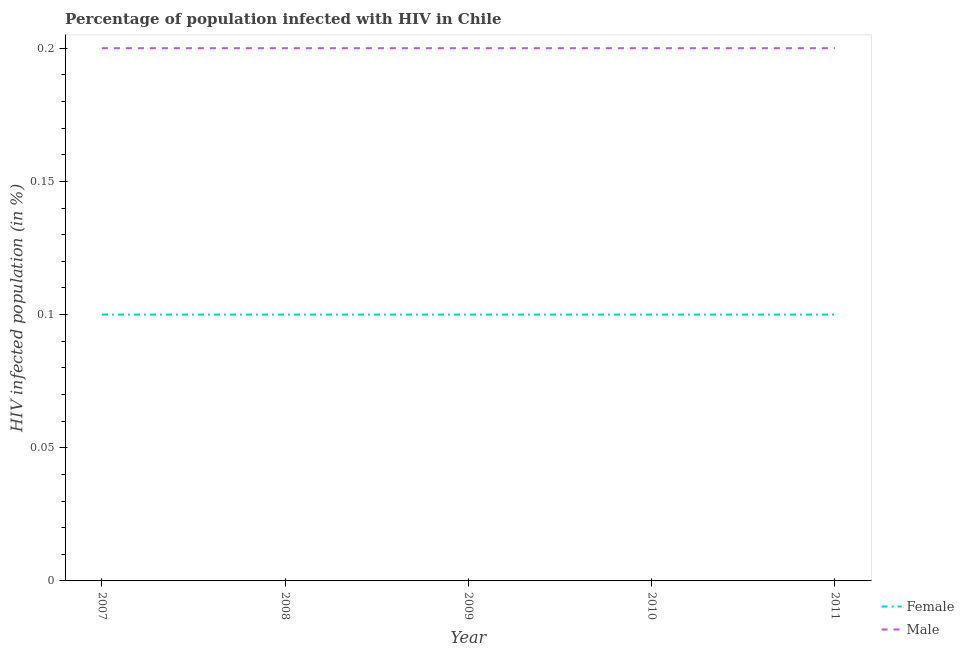Across all years, what is the maximum percentage of females who are infected with hiv?
Offer a terse response. 0.1. What is the difference between the percentage of females who are infected with hiv in 2009 and that in 2010?
Make the answer very short. 0. What is the difference between the percentage of females who are infected with hiv in 2007 and the percentage of males who are infected with hiv in 2011?
Your response must be concise. -0.1. What is the average percentage of males who are infected with hiv per year?
Your response must be concise. 0.2. In the year 2010, what is the difference between the percentage of males who are infected with hiv and percentage of females who are infected with hiv?
Give a very brief answer. 0.1. Is the difference between the percentage of females who are infected with hiv in 2009 and 2010 greater than the difference between the percentage of males who are infected with hiv in 2009 and 2010?
Provide a short and direct response. No. What is the difference between the highest and the lowest percentage of males who are infected with hiv?
Your answer should be compact. 0. Does the percentage of males who are infected with hiv monotonically increase over the years?
Provide a succinct answer. No. Is the percentage of females who are infected with hiv strictly less than the percentage of males who are infected with hiv over the years?
Offer a very short reply. Yes. How many years are there in the graph?
Provide a succinct answer. 5. What is the difference between two consecutive major ticks on the Y-axis?
Make the answer very short. 0.05. Are the values on the major ticks of Y-axis written in scientific E-notation?
Give a very brief answer. No. Does the graph contain any zero values?
Provide a short and direct response. No. Does the graph contain grids?
Offer a terse response. No. Where does the legend appear in the graph?
Your response must be concise. Bottom right. How many legend labels are there?
Keep it short and to the point. 2. How are the legend labels stacked?
Provide a short and direct response. Vertical. What is the title of the graph?
Keep it short and to the point. Percentage of population infected with HIV in Chile. Does "Private consumption" appear as one of the legend labels in the graph?
Provide a short and direct response. No. What is the label or title of the Y-axis?
Give a very brief answer. HIV infected population (in %). What is the HIV infected population (in %) in Female in 2007?
Ensure brevity in your answer.  0.1. What is the HIV infected population (in %) in Female in 2008?
Offer a very short reply. 0.1. What is the HIV infected population (in %) in Male in 2008?
Provide a succinct answer. 0.2. What is the HIV infected population (in %) of Female in 2009?
Provide a succinct answer. 0.1. What is the HIV infected population (in %) in Male in 2009?
Your answer should be very brief. 0.2. What is the HIV infected population (in %) of Male in 2010?
Provide a short and direct response. 0.2. What is the HIV infected population (in %) in Female in 2011?
Your answer should be compact. 0.1. Across all years, what is the maximum HIV infected population (in %) in Female?
Offer a very short reply. 0.1. Across all years, what is the minimum HIV infected population (in %) in Female?
Your response must be concise. 0.1. What is the total HIV infected population (in %) of Female in the graph?
Provide a succinct answer. 0.5. What is the total HIV infected population (in %) of Male in the graph?
Offer a very short reply. 1. What is the difference between the HIV infected population (in %) in Female in 2007 and that in 2009?
Offer a very short reply. 0. What is the difference between the HIV infected population (in %) of Male in 2007 and that in 2009?
Keep it short and to the point. 0. What is the difference between the HIV infected population (in %) of Female in 2007 and that in 2010?
Offer a very short reply. 0. What is the difference between the HIV infected population (in %) in Male in 2007 and that in 2010?
Keep it short and to the point. 0. What is the difference between the HIV infected population (in %) of Male in 2009 and that in 2010?
Make the answer very short. 0. What is the difference between the HIV infected population (in %) in Female in 2009 and that in 2011?
Keep it short and to the point. 0. What is the difference between the HIV infected population (in %) of Female in 2010 and that in 2011?
Offer a terse response. 0. What is the difference between the HIV infected population (in %) in Male in 2010 and that in 2011?
Your answer should be compact. 0. What is the difference between the HIV infected population (in %) in Female in 2007 and the HIV infected population (in %) in Male in 2008?
Offer a very short reply. -0.1. What is the difference between the HIV infected population (in %) of Female in 2007 and the HIV infected population (in %) of Male in 2009?
Provide a succinct answer. -0.1. What is the difference between the HIV infected population (in %) of Female in 2008 and the HIV infected population (in %) of Male in 2010?
Provide a short and direct response. -0.1. What is the difference between the HIV infected population (in %) of Female in 2008 and the HIV infected population (in %) of Male in 2011?
Provide a short and direct response. -0.1. What is the difference between the HIV infected population (in %) of Female in 2009 and the HIV infected population (in %) of Male in 2010?
Offer a terse response. -0.1. What is the average HIV infected population (in %) in Female per year?
Your answer should be compact. 0.1. In the year 2007, what is the difference between the HIV infected population (in %) in Female and HIV infected population (in %) in Male?
Give a very brief answer. -0.1. In the year 2008, what is the difference between the HIV infected population (in %) of Female and HIV infected population (in %) of Male?
Give a very brief answer. -0.1. In the year 2009, what is the difference between the HIV infected population (in %) of Female and HIV infected population (in %) of Male?
Give a very brief answer. -0.1. In the year 2011, what is the difference between the HIV infected population (in %) in Female and HIV infected population (in %) in Male?
Make the answer very short. -0.1. What is the ratio of the HIV infected population (in %) in Male in 2007 to that in 2008?
Make the answer very short. 1. What is the ratio of the HIV infected population (in %) of Female in 2008 to that in 2009?
Keep it short and to the point. 1. What is the ratio of the HIV infected population (in %) in Female in 2008 to that in 2010?
Provide a succinct answer. 1. What is the ratio of the HIV infected population (in %) of Male in 2008 to that in 2010?
Offer a very short reply. 1. What is the ratio of the HIV infected population (in %) in Female in 2009 to that in 2011?
Your response must be concise. 1. What is the ratio of the HIV infected population (in %) of Male in 2009 to that in 2011?
Your answer should be very brief. 1. What is the ratio of the HIV infected population (in %) of Male in 2010 to that in 2011?
Keep it short and to the point. 1. What is the difference between the highest and the second highest HIV infected population (in %) in Male?
Ensure brevity in your answer.  0. What is the difference between the highest and the lowest HIV infected population (in %) of Female?
Make the answer very short. 0. 